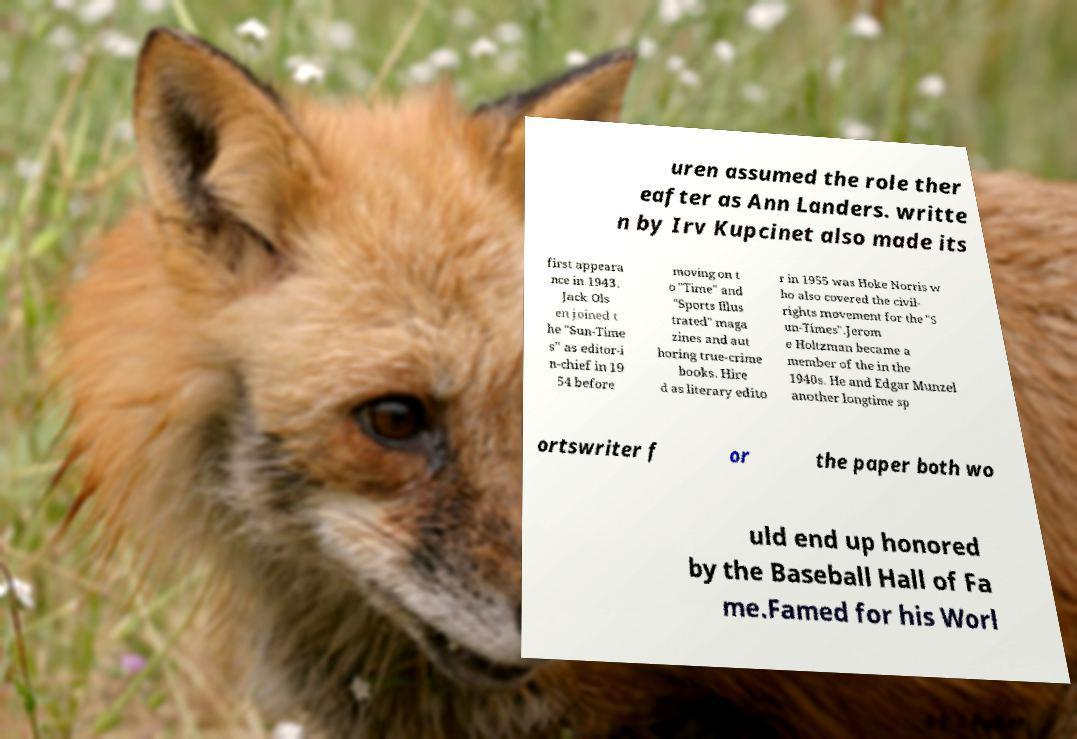Can you read and provide the text displayed in the image?This photo seems to have some interesting text. Can you extract and type it out for me? uren assumed the role ther eafter as Ann Landers. writte n by Irv Kupcinet also made its first appeara nce in 1943. Jack Ols en joined t he "Sun-Time s" as editor-i n-chief in 19 54 before moving on t o "Time" and "Sports Illus trated" maga zines and aut horing true-crime books. Hire d as literary edito r in 1955 was Hoke Norris w ho also covered the civil- rights movement for the "S un-Times".Jerom e Holtzman became a member of the in the 1940s. He and Edgar Munzel another longtime sp ortswriter f or the paper both wo uld end up honored by the Baseball Hall of Fa me.Famed for his Worl 